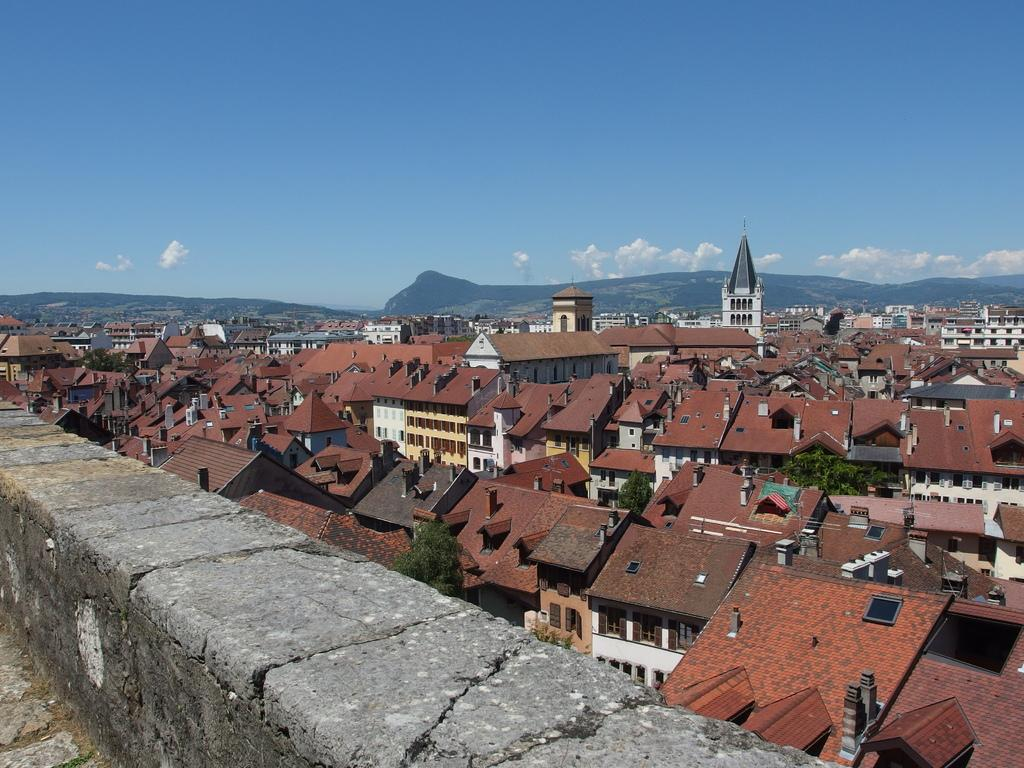What is located on the left side of the image? There is a wall on the left side of the image. What can be seen in the background of the image? In the background of the image, there are buildings, houses, roofs, windows, trees, mountains, and clouds in the sky. What credit score do the girls in the image have? There are no girls present in the image, so it is not possible to determine their credit scores. 